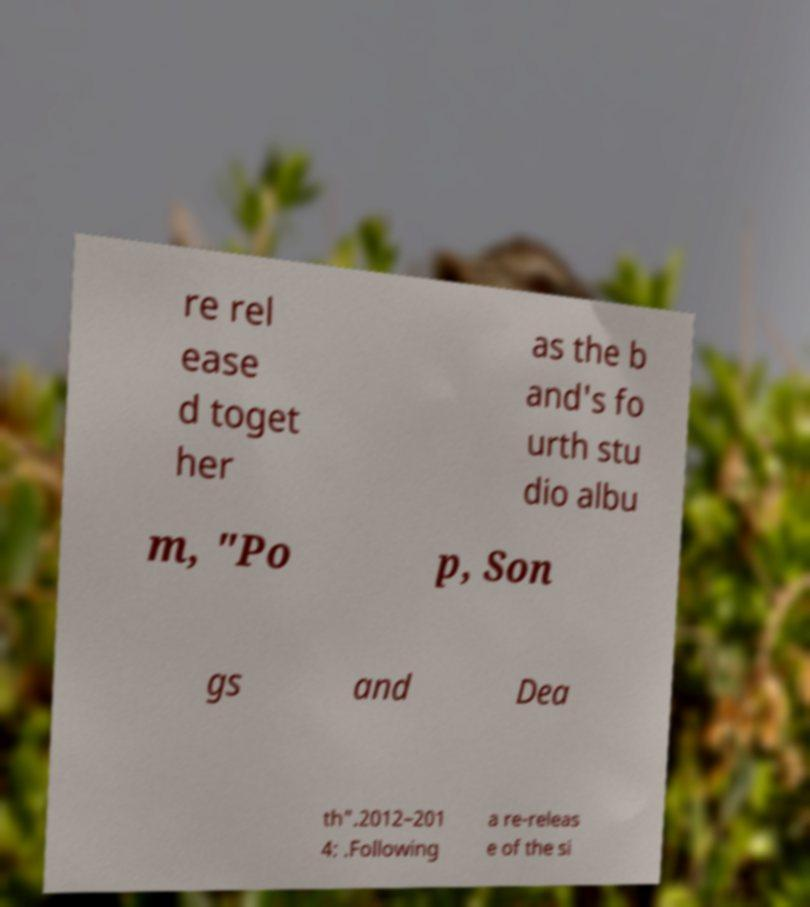There's text embedded in this image that I need extracted. Can you transcribe it verbatim? re rel ease d toget her as the b and's fo urth stu dio albu m, "Po p, Son gs and Dea th".2012–201 4: .Following a re-releas e of the si 